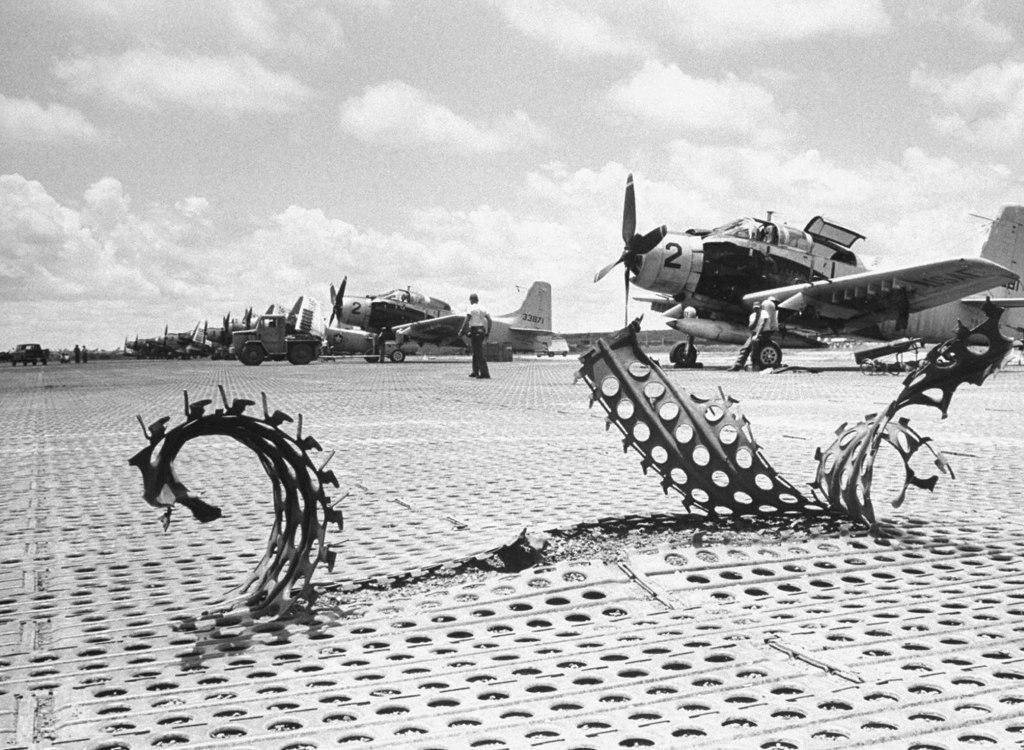In one or two sentences, can you explain what this image depicts? This picture is in black and white. In the center, there are helicopters in a row. In the center, there is a man. At the bottom, there are metals. On the top, there is a sky with clouds. 